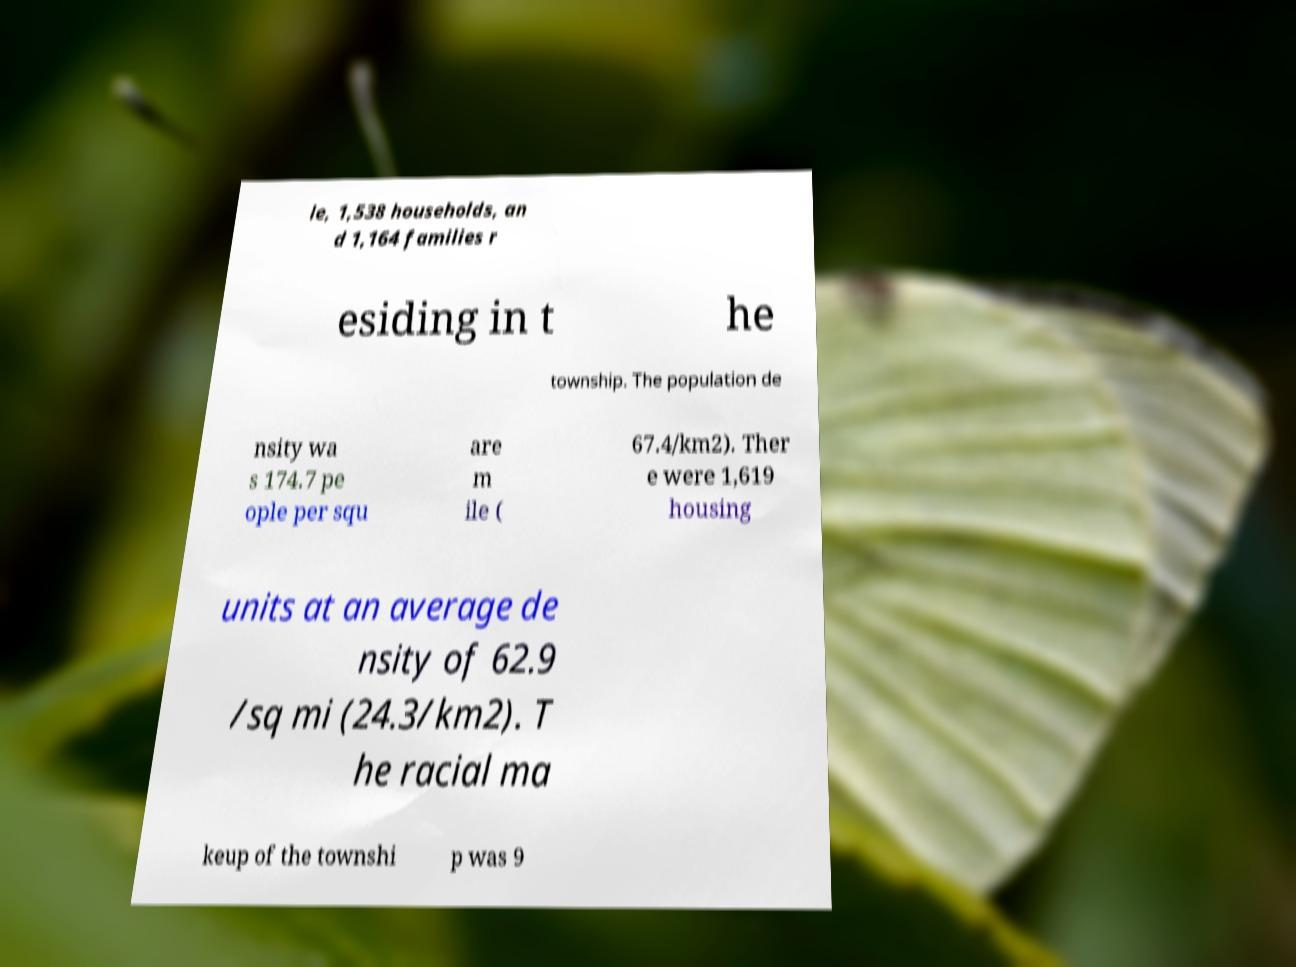For documentation purposes, I need the text within this image transcribed. Could you provide that? le, 1,538 households, an d 1,164 families r esiding in t he township. The population de nsity wa s 174.7 pe ople per squ are m ile ( 67.4/km2). Ther e were 1,619 housing units at an average de nsity of 62.9 /sq mi (24.3/km2). T he racial ma keup of the townshi p was 9 